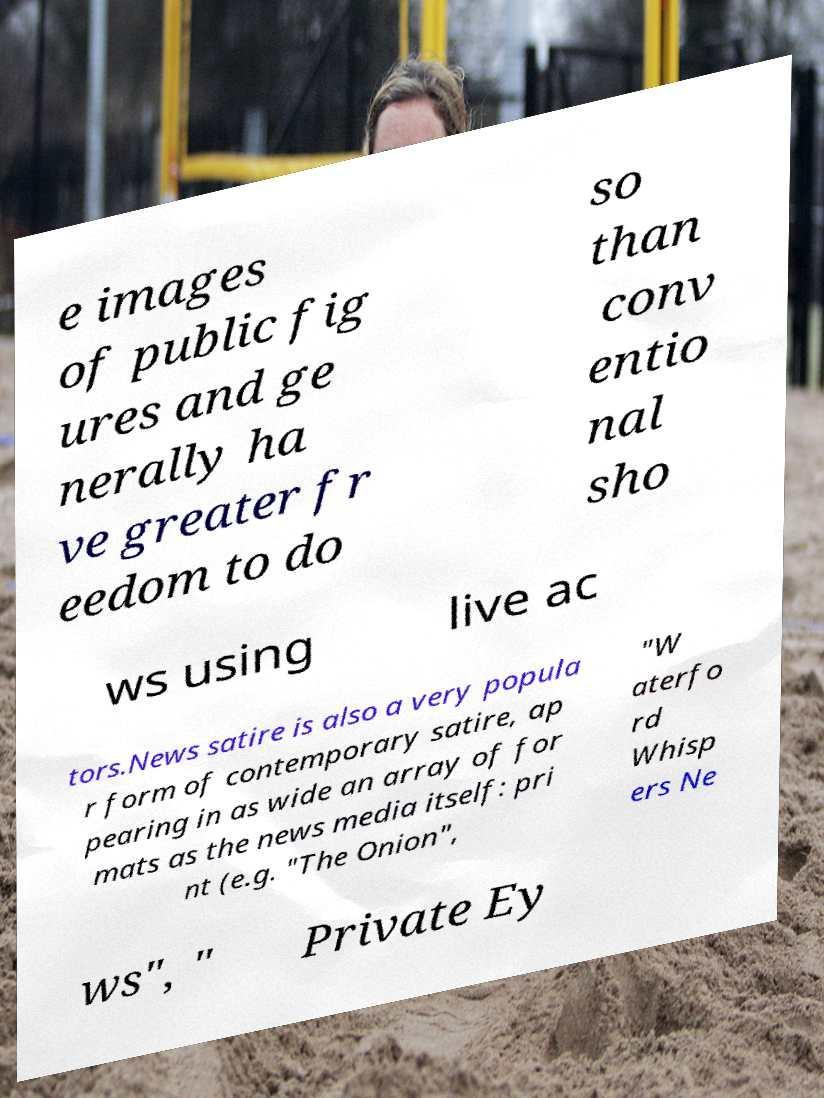There's text embedded in this image that I need extracted. Can you transcribe it verbatim? e images of public fig ures and ge nerally ha ve greater fr eedom to do so than conv entio nal sho ws using live ac tors.News satire is also a very popula r form of contemporary satire, ap pearing in as wide an array of for mats as the news media itself: pri nt (e.g. "The Onion", "W aterfo rd Whisp ers Ne ws", " Private Ey 